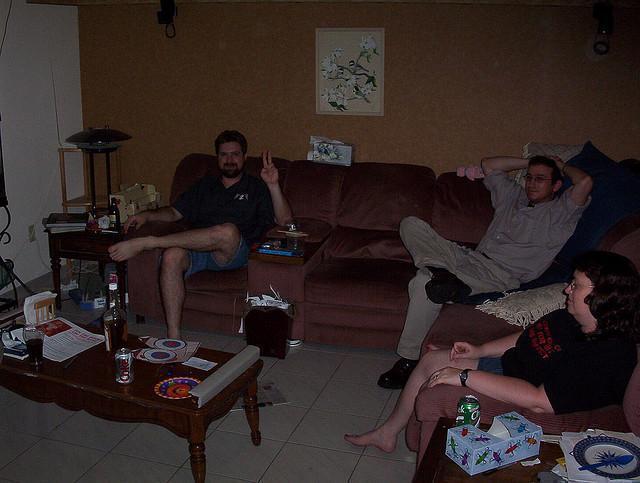How many boys in the picture?
Give a very brief answer. 2. How many total bottles are pictured?
Give a very brief answer. 1. How many men are wearing hats?
Give a very brief answer. 0. How many feet are in the picture?
Give a very brief answer. 6. How many pictures on wall?
Give a very brief answer. 1. How many people are sitting?
Give a very brief answer. 3. How many people are in the photo?
Give a very brief answer. 3. How many people are wearing hats?
Give a very brief answer. 0. How many people are wearing glasses?
Give a very brief answer. 2. How many people are posing?
Give a very brief answer. 1. How many chairs are visible?
Give a very brief answer. 1. How many chairs are there?
Give a very brief answer. 1. How many shoes are shown?
Give a very brief answer. 2. How many people are wearing gray shirts?
Give a very brief answer. 1. How many couches are in the picture?
Give a very brief answer. 2. How many people can be seen?
Give a very brief answer. 3. 